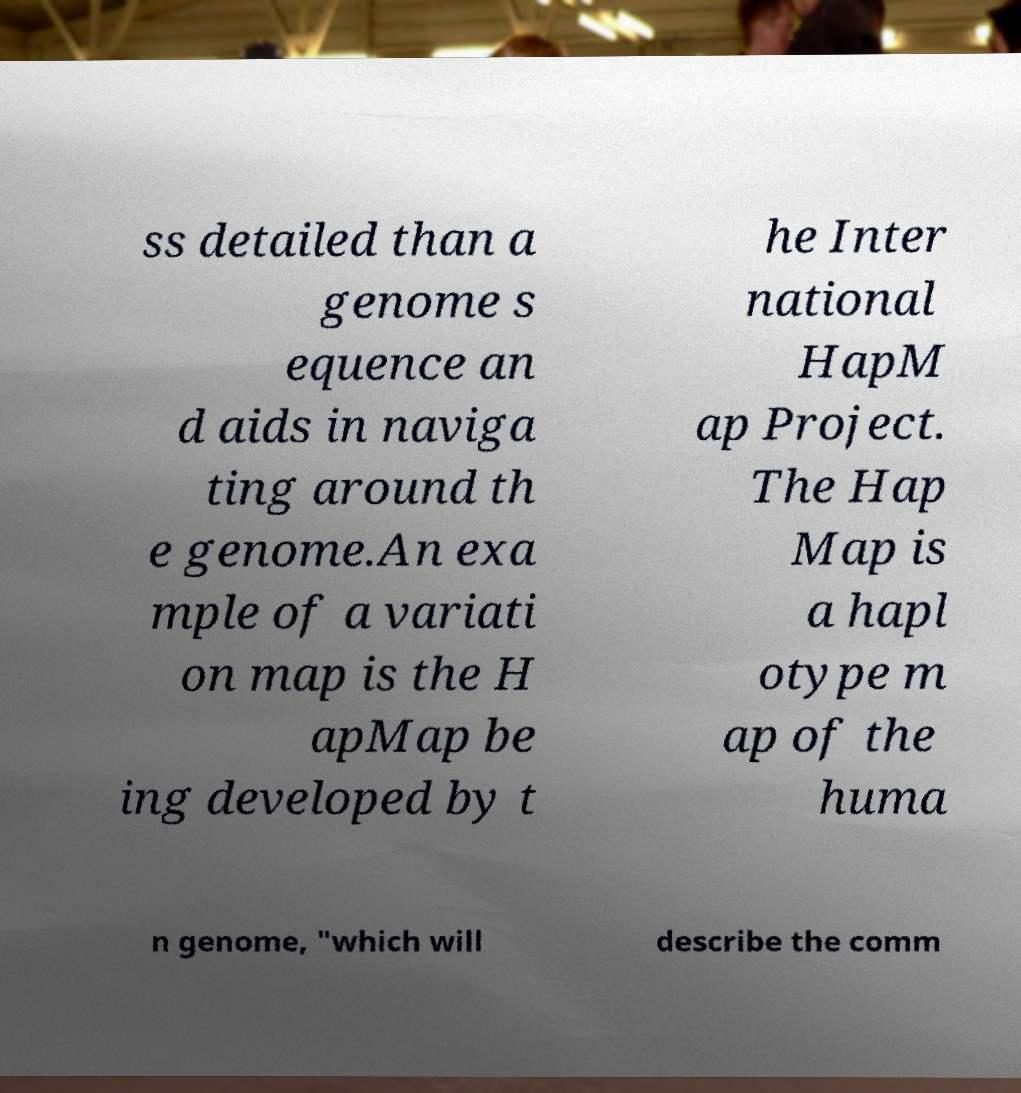Can you accurately transcribe the text from the provided image for me? ss detailed than a genome s equence an d aids in naviga ting around th e genome.An exa mple of a variati on map is the H apMap be ing developed by t he Inter national HapM ap Project. The Hap Map is a hapl otype m ap of the huma n genome, "which will describe the comm 